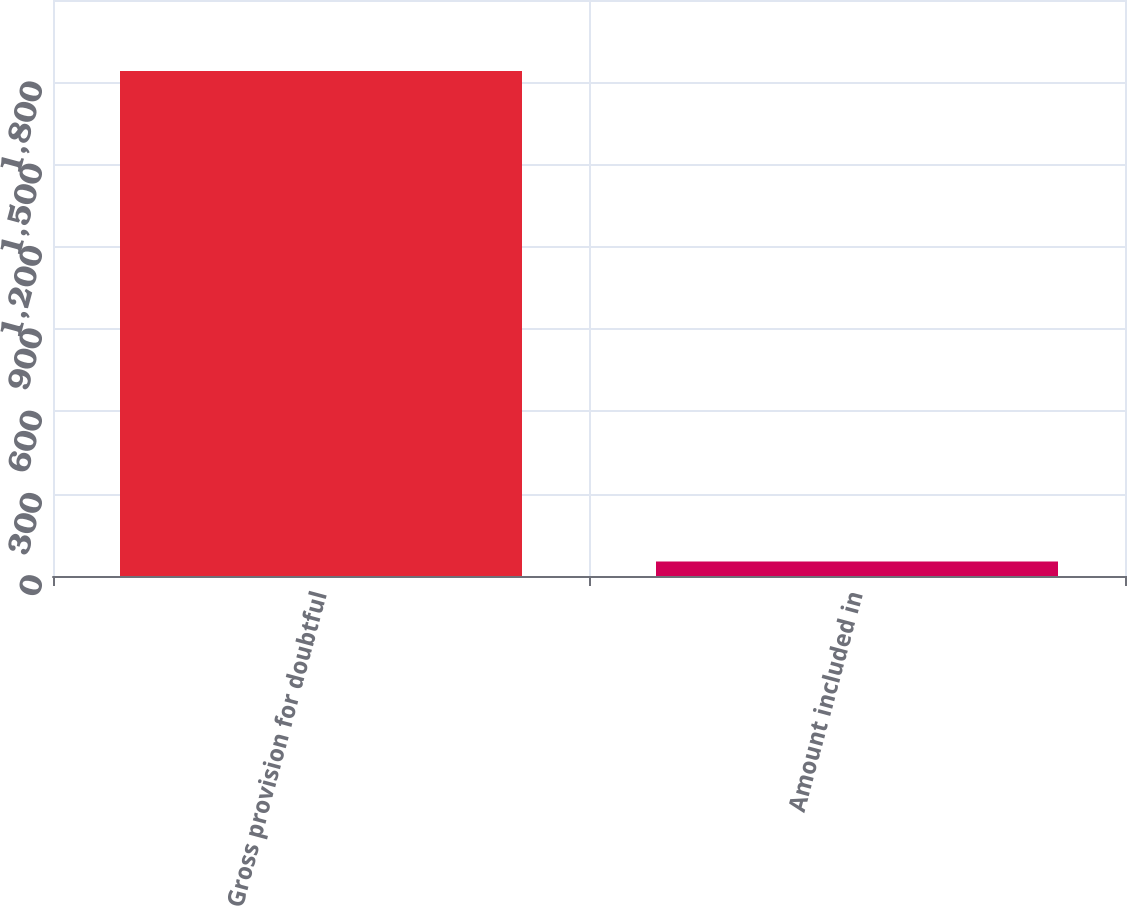Convert chart. <chart><loc_0><loc_0><loc_500><loc_500><bar_chart><fcel>Gross provision for doubtful<fcel>Amount included in<nl><fcel>1841<fcel>53<nl></chart> 